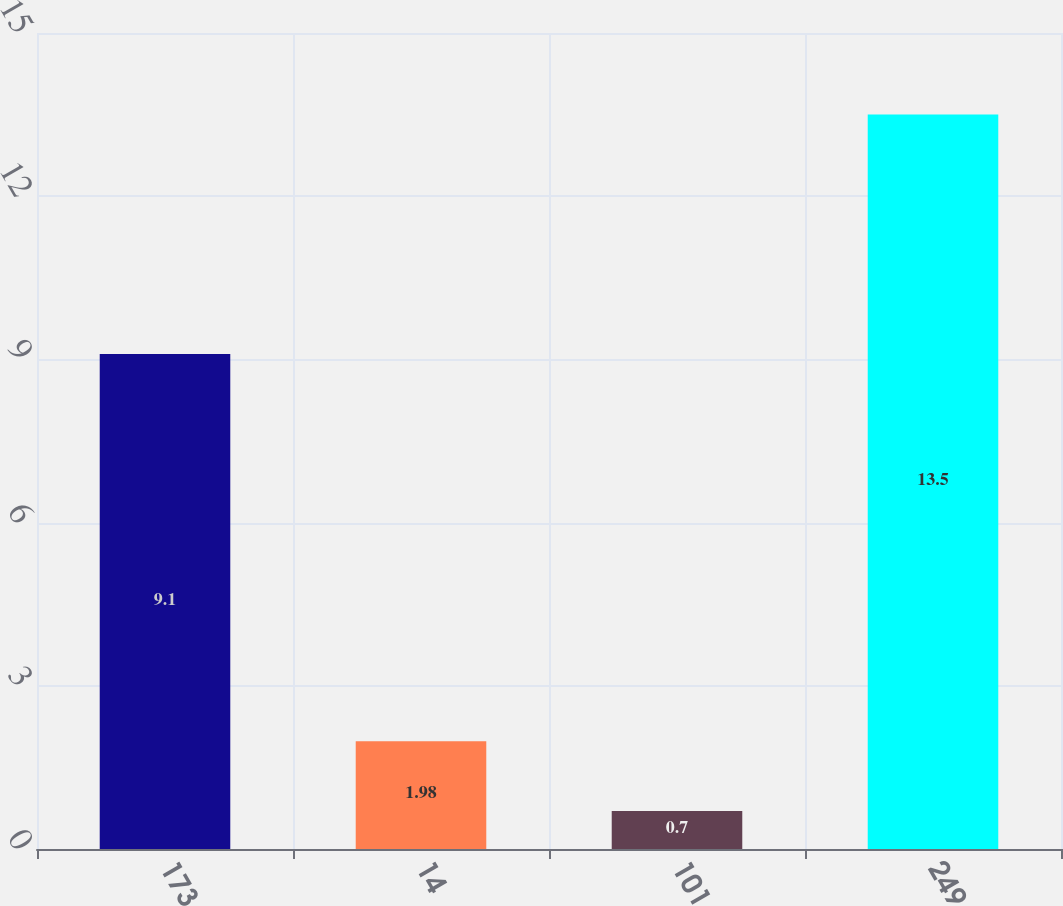Convert chart to OTSL. <chart><loc_0><loc_0><loc_500><loc_500><bar_chart><fcel>173<fcel>14<fcel>101<fcel>249<nl><fcel>9.1<fcel>1.98<fcel>0.7<fcel>13.5<nl></chart> 